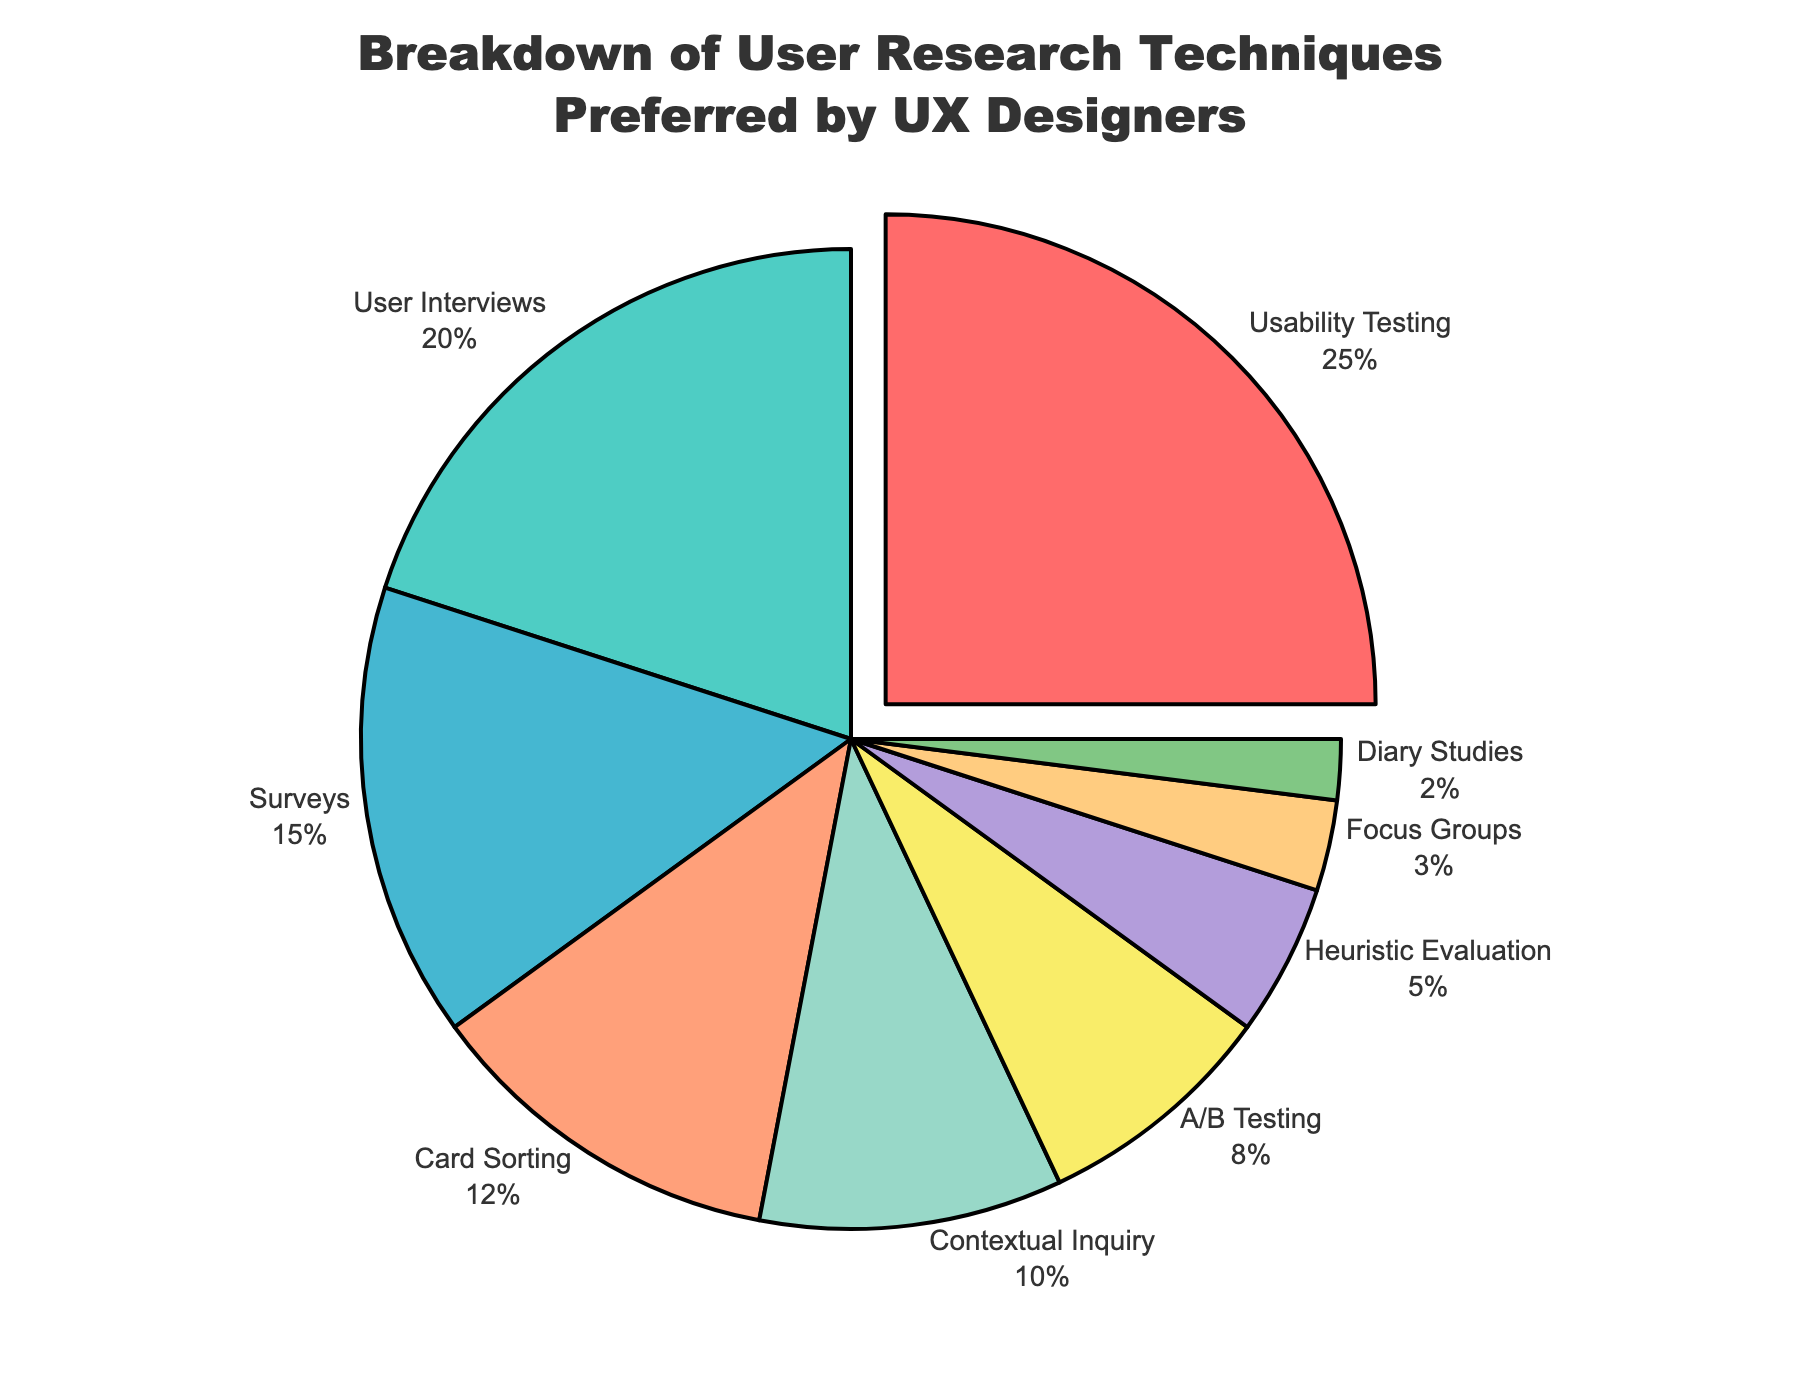Which user research technique is the most preferred by UX designers? Identify the largest segment in the pie chart, which is visually pulled out and labeled with the highest percentage.
Answer: Usability Testing How much more preferred is Usability Testing compared to Contextual Inquiry? Find the percentage of Usability Testing (25%) and Contextual Inquiry (10%) from the pie chart and subtract the latter from the former: 25% - 10%.
Answer: 15% What is the combined percentage of User Interviews, Surveys, and Card Sorting? Add the percentages of User Interviews (20%), Surveys (15%), and Card Sorting (12%). The calculation is 20% + 15% + 12%.
Answer: 47% Which research technique has the smallest segment in the pie chart, and what is its percentage? Locate the smallest slice in the pie chart, which is labeled with the lowest percentage.
Answer: Diary Studies, 2% Arrange User Interviews, A/B Testing, and Focus Groups in ascending order based on their percentage. Compare the percentages of User Interviews (20%), A/B Testing (8%), and Focus Groups (3%). Arrange them from smallest to largest.
Answer: Focus Groups, A/B Testing, User Interviews By how much is the percentage of Heuristic Evaluation greater than Diary Studies? Find the percentage of Heuristic Evaluation (5%) and Diary Studies (2%) from the pie chart and subtract the latter from the former: 5% - 2%.
Answer: 3% What is the cumulative percentage of techniques that have a percentage of 10% or greater? Identify techniques with 10% or higher percentages: Usability Testing (25%), User Interviews (20%), Surveys (15%), Card Sorting (12%), Contextual Inquiry (10%). Add them: 25% + 20% + 15% + 12% + 10%.
Answer: 82% Which technique is represented by the green segment in the pie chart? Identify the color assigned to each segment, and find the one that is green.
Answer: User Interviews How many techniques have a percentage less than or equal to 10%? Count the segments with percentages equal to or less than 10%: Contextual Inquiry (10%), A/B Testing (8%), Heuristic Evaluation (5%), Focus Groups (3%), Diary Studies (2%).
Answer: 5 What's the total percentage of all user research techniques combined? The sum of all segments' percentages should logically add up to 100%, representing the total distribution.
Answer: 100% 